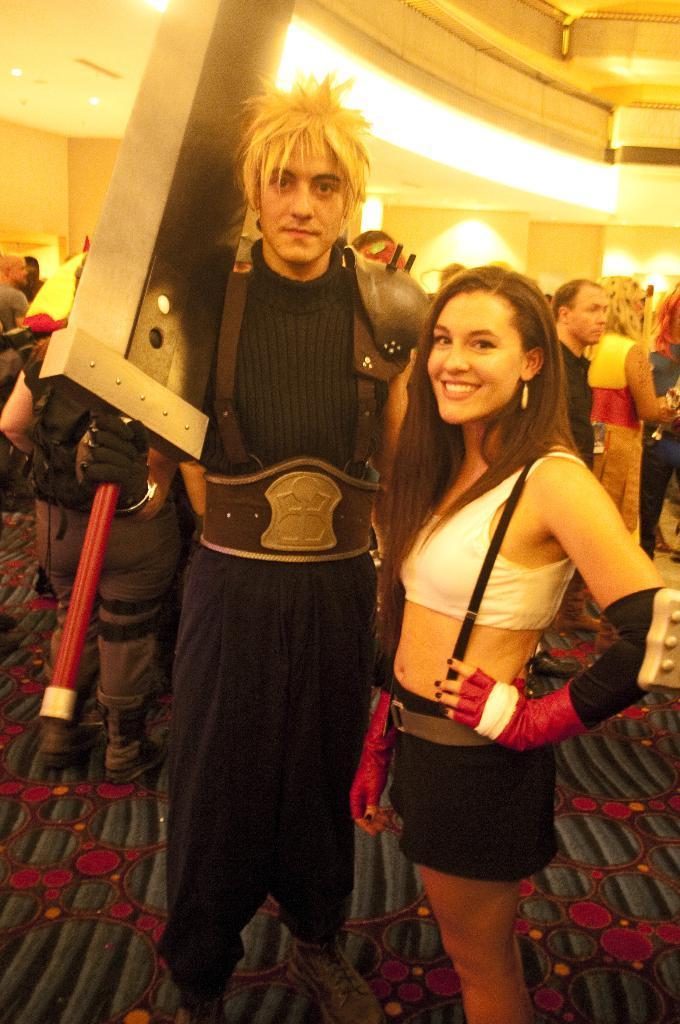How would you summarize this image in a sentence or two? In the foreground of this image, there is a woman and a man standing on the floor and the man is holding a sword like an object. In the background, there are people and few lights to the ceiling. 